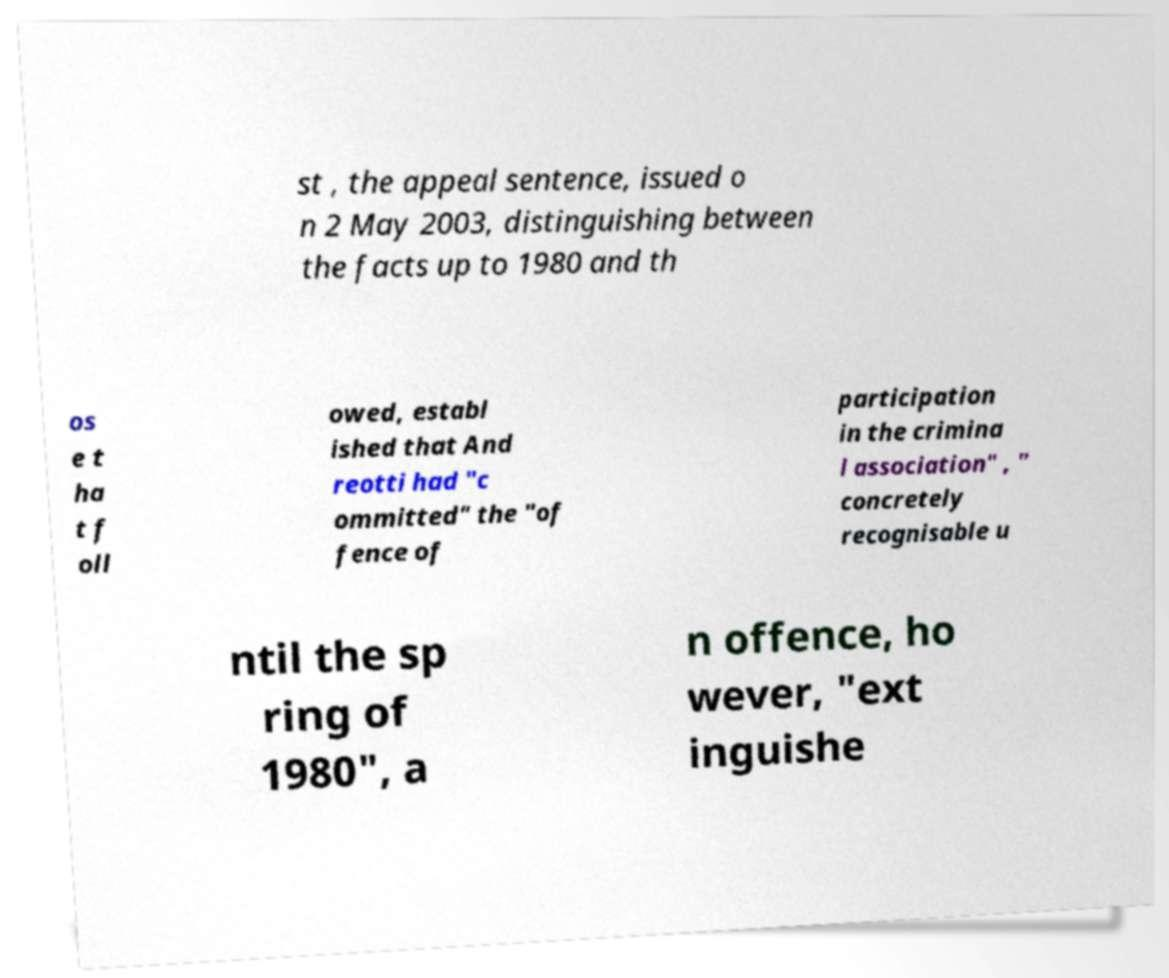Please read and relay the text visible in this image. What does it say? st , the appeal sentence, issued o n 2 May 2003, distinguishing between the facts up to 1980 and th os e t ha t f oll owed, establ ished that And reotti had "c ommitted" the "of fence of participation in the crimina l association" , " concretely recognisable u ntil the sp ring of 1980", a n offence, ho wever, "ext inguishe 